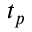<formula> <loc_0><loc_0><loc_500><loc_500>t _ { p }</formula> 